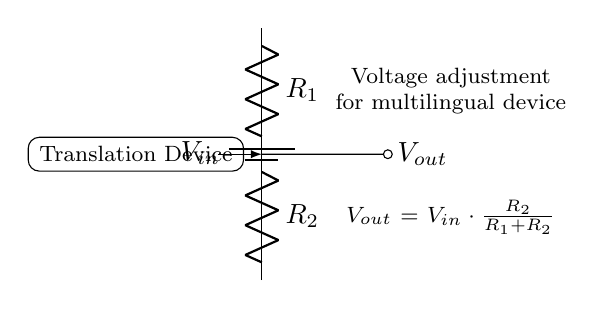What is the input voltage in this circuit? The input voltage, denoted as \(V_{in}\), is shown at the top of the circuit diagram next to the battery symbol.
Answer: \(V_{in}\) What are the values of the resistors in this voltage divider? The resistor values, labeled \(R_1\) and \(R_2\), do not have specific numerical values in the diagram; however, they are essential components of the voltage divider.
Answer: \(R_1, R_2\) What is the formula for \(V_{out}\)? The formula for the output voltage \(V_{out}\) appears on the diagram. It is calculated using the values of the resistors and the input voltage.
Answer: \(V_{out} = V_{in} \cdot \frac{R_2}{R_1 + R_2}\) How does \(R_2\) affect \(V_{out}\)? Increasing the value of \(R_2\) directly increases \(V_{out}\) because it is in direct proportion to \(R_2\) in the voltage divider formula.
Answer: Increases In this circuit, what does the node labeled "Translation Device" represent? The node labeled "Translation Device" indicates where the controlled output voltage \(V_{out}\) will be used to power or control the translation device.
Answer: Controlled output voltage If \(R_1\) is doubled while \(R_2\) remains the same, how does \(V_{out}\) change? Doubling \(R_1\) will increase the total resistance in the denominator of the output voltage formula, thus decreasing \(V_{out}\).
Answer: Decreases 